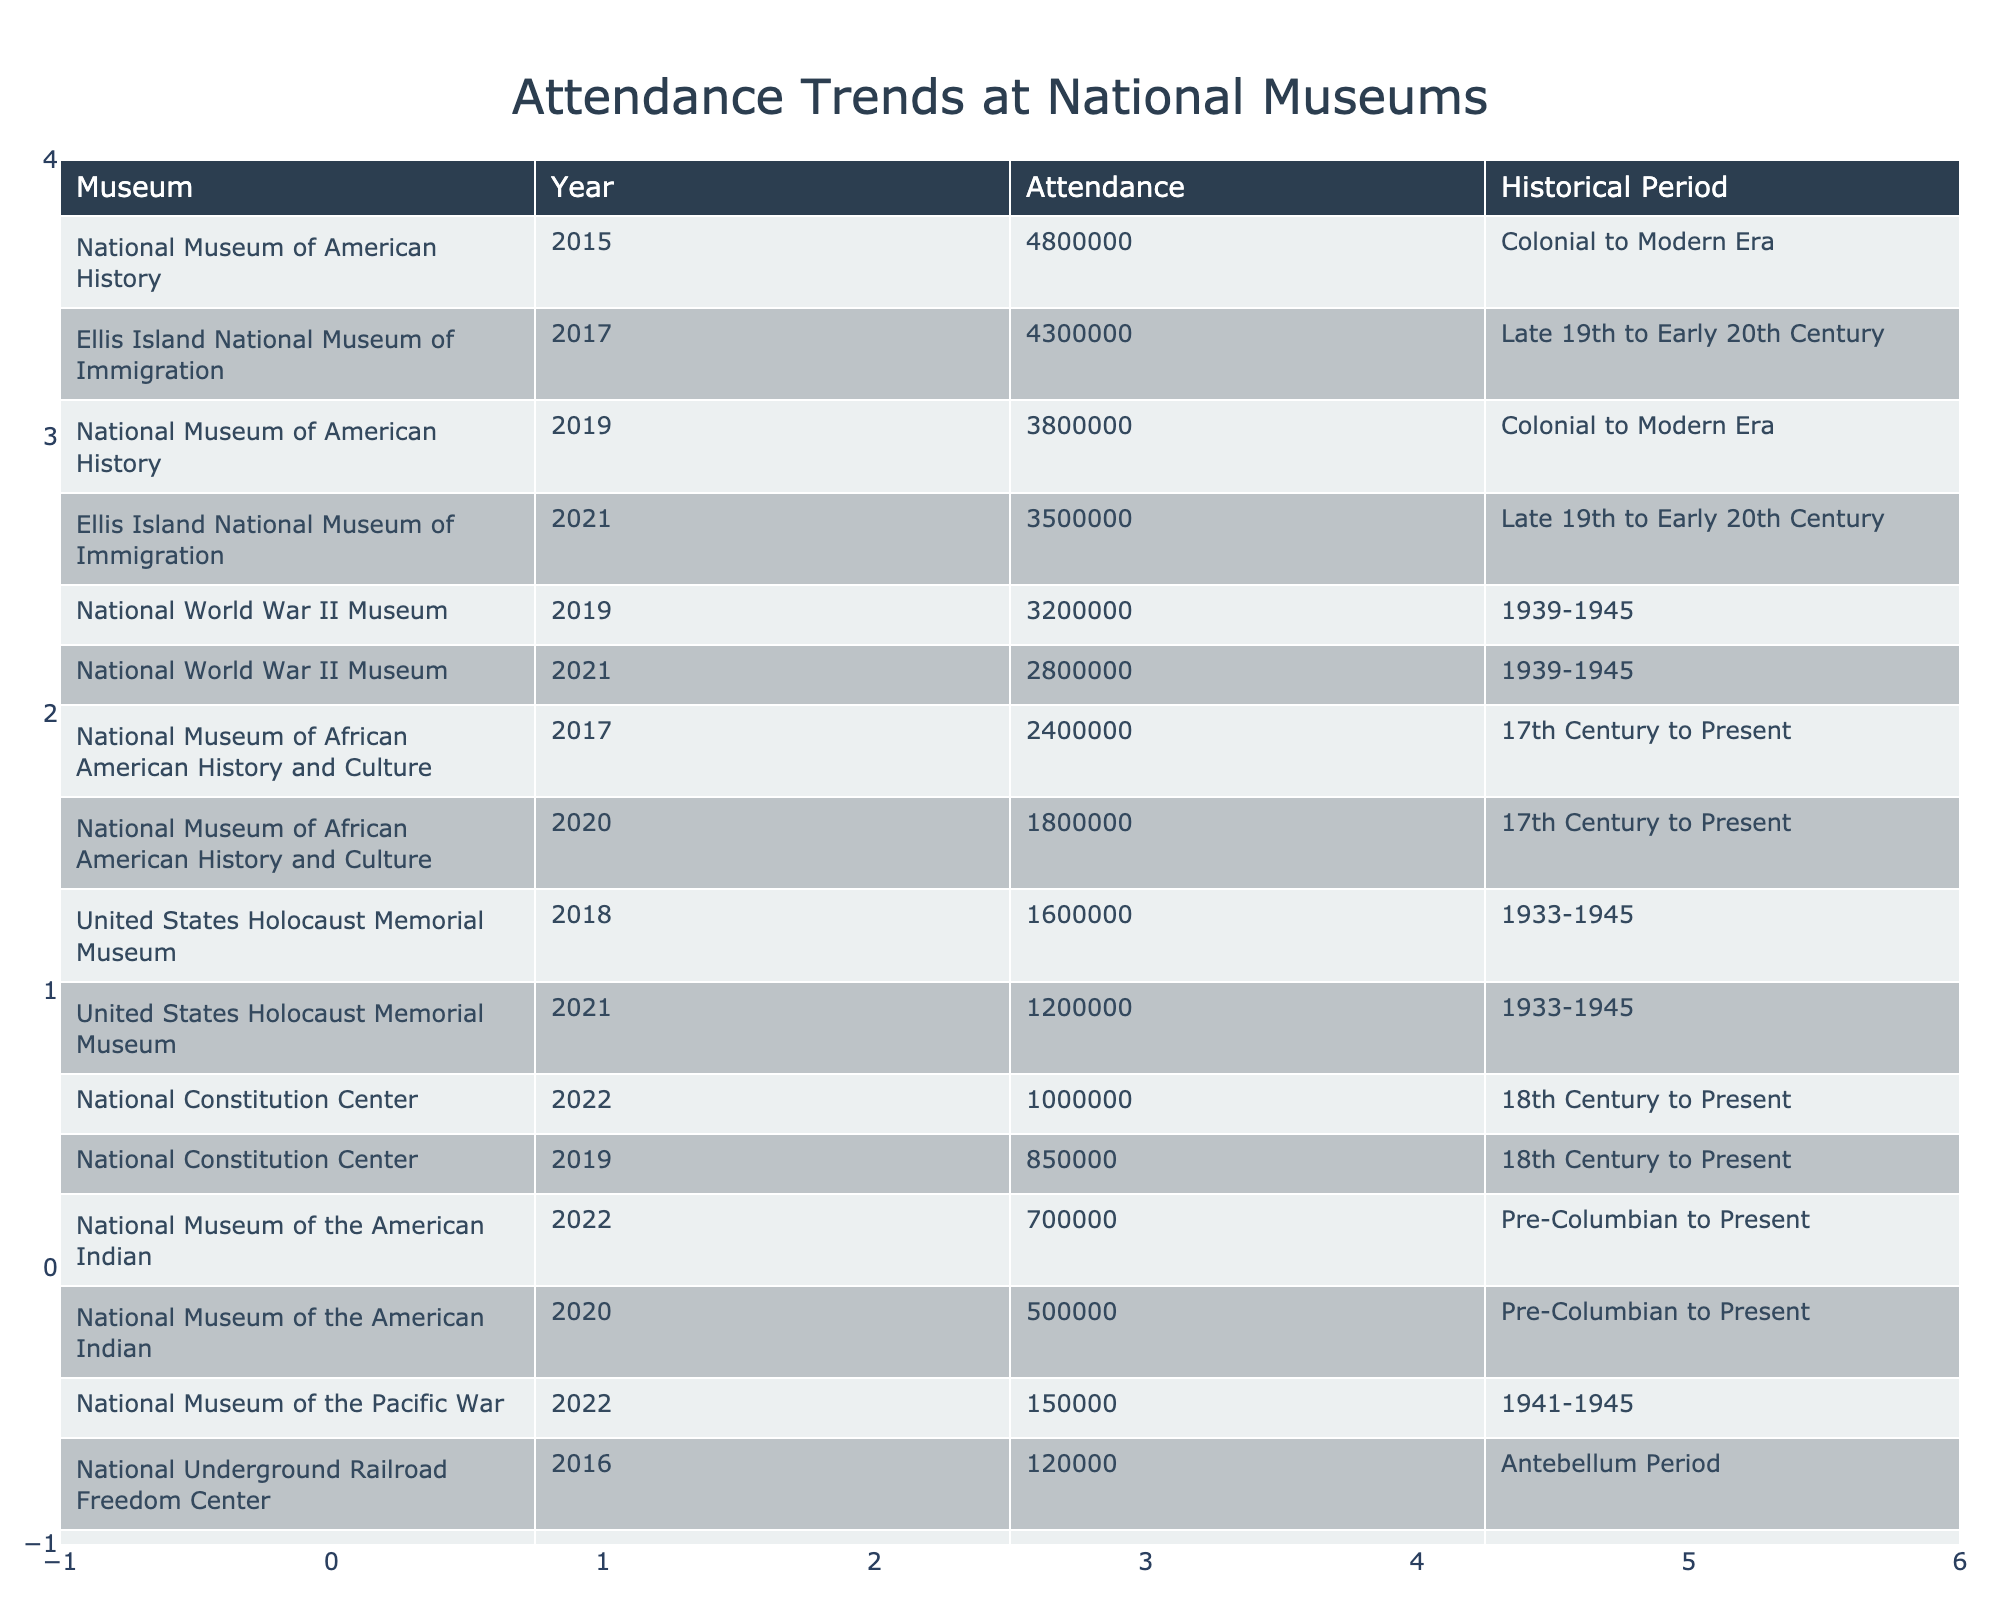What is the attendance of the National Museum of American History in 2019? The table lists the attendance for the National Museum of American History in 2019 as 3,800,000 visitors.
Answer: 3,800,000 Which museum had the highest attendance in 2015? The table shows that the National Museum of American History had the highest attendance in 2015 with 4,800,000 visitors.
Answer: National Museum of American History What is the total attendance for the National Civil War Museum over all the years listed? Adding the attendances of the National Civil War Museum: 40,000 (2016) + 25,000 (2020) = 65,000.
Answer: 65,000 Did the National Museum of the American Indian have an increase in attendance from 2020 to 2022? The attendance rose from 500,000 in 2020 to 700,000 in 2022, indicating an increase of 200,000.
Answer: Yes Which historical period had the lowest average attendance across all museums? The average attendance for the various historical periods can be calculated: the Antebellum Period (120,000 + 100,000) has an average of 110,000; the Civil War Period (40,000 + 25,000) has an average of 32,500. Comparing averages, the Civil War Period has the lowest.
Answer: Civil War Period How many visitors did the United States Holocaust Memorial Museum attract in 2021? According to the table, the attendance of the United States Holocaust Memorial Museum in 2021 was 1,200,000 visitors.
Answer: 1,200,000 What percentage of the attendance of Ellis Island National Museum of Immigration in 2017 does its 2021 attendance represent? The attendance in 2017 was 4,300,000 and in 2021 it was 3,500,000. To calculate the percentage: (3,500,000 / 4,300,000) * 100 = approximately 81.4%.
Answer: Approximately 81.4% How does the attendance of the National World War II Museum in 2021 compare to its attendance in 2019? The attendance in 2021 was 2,800,000, which is a decrease from 3,200,000 in 2019, showing a decline of 400,000.
Answer: Decreased by 400,000 What is the total attendance for all museums focusing on the 18th Century to Present period? The National Constitution Center hosted 850,000 (2019) and 1,000,000 (2022), while the National Museum of African American History and Culture had 2,400,000 (2017) and 1,800,000 (2020). Adding these totals gives: 850,000 + 1,000,000 + 2,400,000 + 1,800,000 = 6,050,000.
Answer: 6,050,000 Which year saw the lowest attendance at the National Civil War Museum? The table indicates that the lowest attendance at the National Civil War Museum occurred in 2020 with 25,000 visitors.
Answer: 2020 